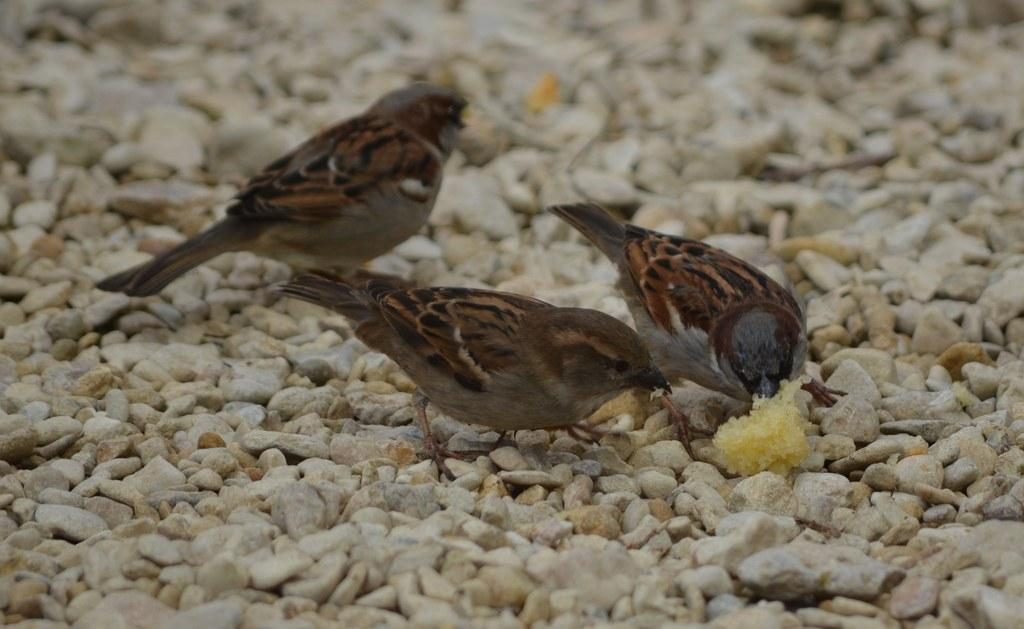How many birds are in the image? There are three sparrows in the image. What are the sparrows standing on? The sparrows are on stones. What type of society do the sparrows belong to in the image? The image does not provide information about the sparrows belonging to any society. 